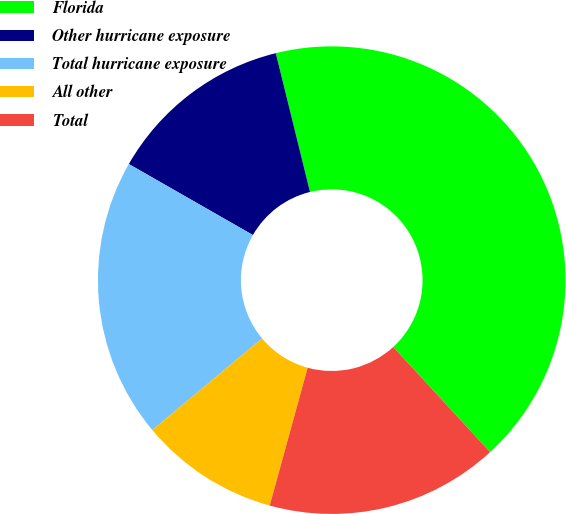Convert chart. <chart><loc_0><loc_0><loc_500><loc_500><pie_chart><fcel>Florida<fcel>Other hurricane exposure<fcel>Total hurricane exposure<fcel>All other<fcel>Total<nl><fcel>42.0%<fcel>12.88%<fcel>19.35%<fcel>9.65%<fcel>16.12%<nl></chart> 